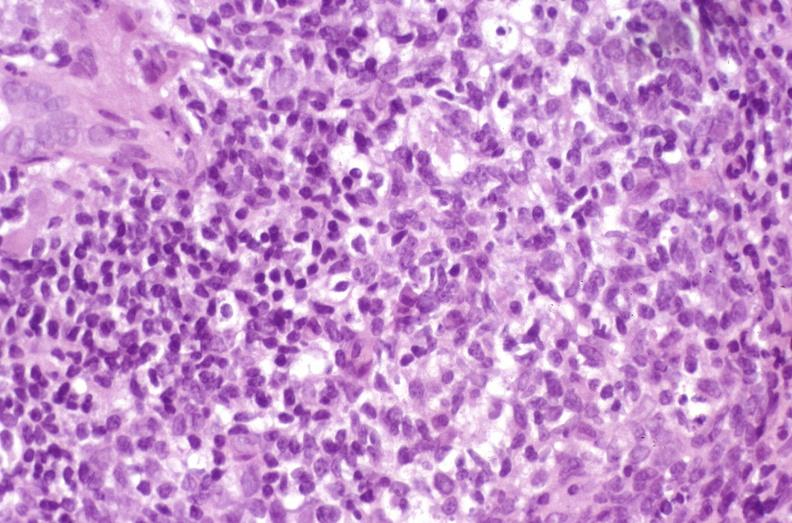s hepatobiliary present?
Answer the question using a single word or phrase. Yes 